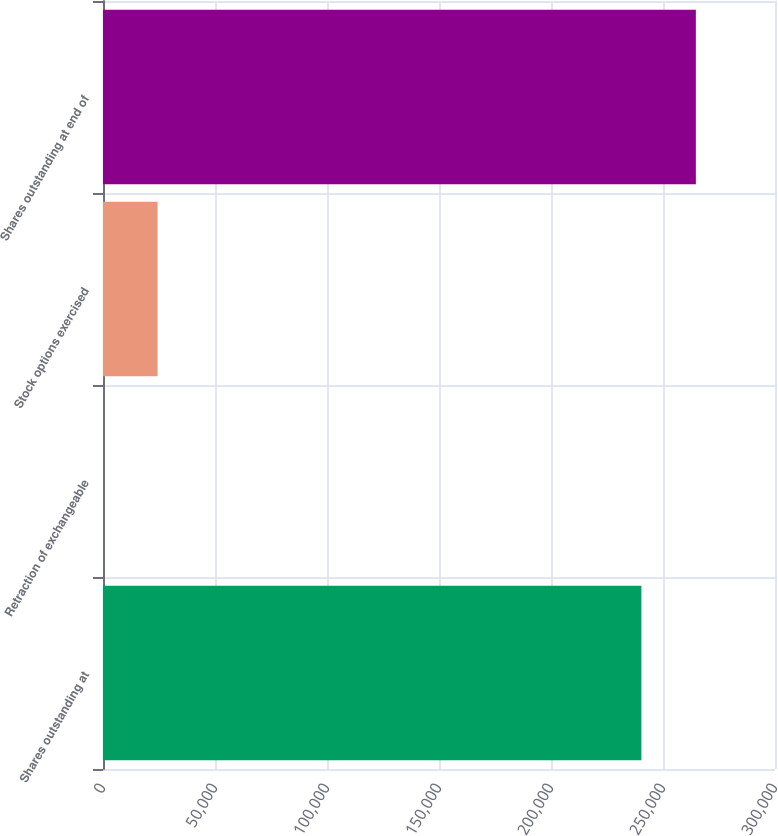Convert chart. <chart><loc_0><loc_0><loc_500><loc_500><bar_chart><fcel>Shares outstanding at<fcel>Retraction of exchangeable<fcel>Stock options exercised<fcel>Shares outstanding at end of<nl><fcel>240361<fcel>66<fcel>24373.2<fcel>264668<nl></chart> 